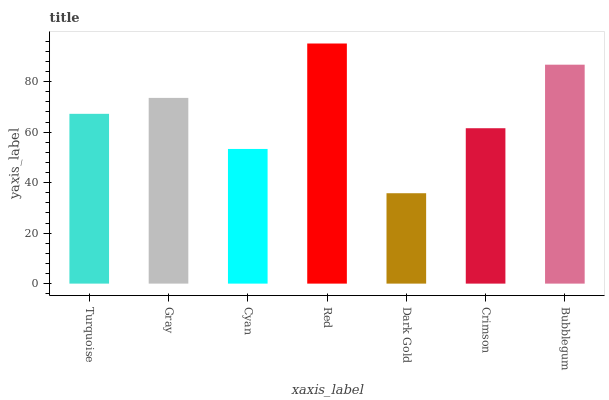Is Dark Gold the minimum?
Answer yes or no. Yes. Is Red the maximum?
Answer yes or no. Yes. Is Gray the minimum?
Answer yes or no. No. Is Gray the maximum?
Answer yes or no. No. Is Gray greater than Turquoise?
Answer yes or no. Yes. Is Turquoise less than Gray?
Answer yes or no. Yes. Is Turquoise greater than Gray?
Answer yes or no. No. Is Gray less than Turquoise?
Answer yes or no. No. Is Turquoise the high median?
Answer yes or no. Yes. Is Turquoise the low median?
Answer yes or no. Yes. Is Gray the high median?
Answer yes or no. No. Is Gray the low median?
Answer yes or no. No. 